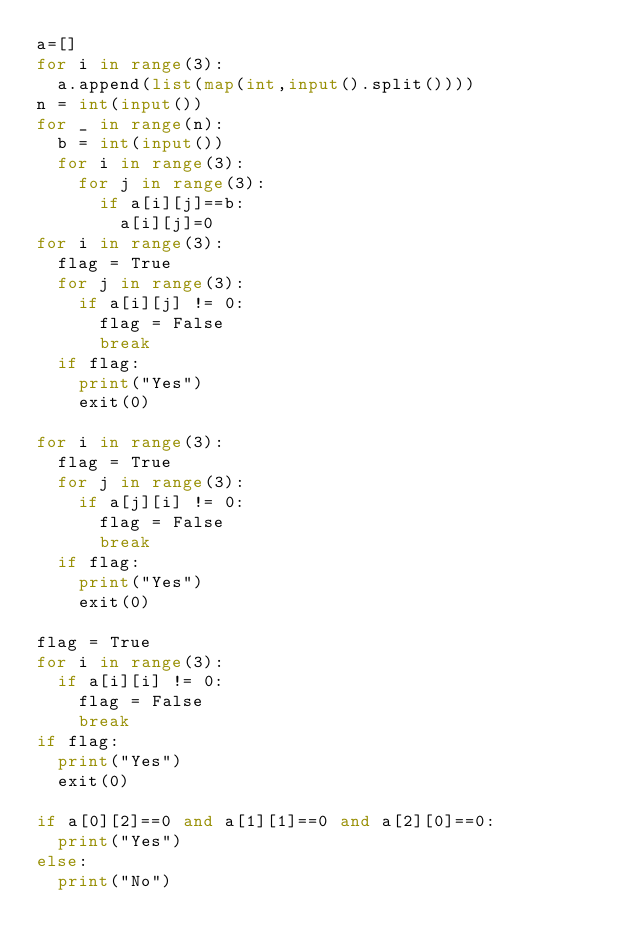Convert code to text. <code><loc_0><loc_0><loc_500><loc_500><_Python_>a=[]
for i in range(3):
	a.append(list(map(int,input().split())))
n = int(input())
for _ in range(n):
	b = int(input())
	for i in range(3):
		for j in range(3):
			if a[i][j]==b:
				a[i][j]=0
for i in range(3):
	flag = True
	for j in range(3):
		if a[i][j] != 0:
			flag = False
			break
	if flag:
		print("Yes")
		exit(0)

for i in range(3):
	flag = True
	for j in range(3):
		if a[j][i] != 0:
			flag = False
			break
	if flag:
		print("Yes")
		exit(0)

flag = True
for i in range(3):
	if a[i][i] != 0:
		flag = False
		break
if flag:
	print("Yes")
	exit(0)

if a[0][2]==0 and a[1][1]==0 and a[2][0]==0:
	print("Yes")
else:
	print("No")</code> 